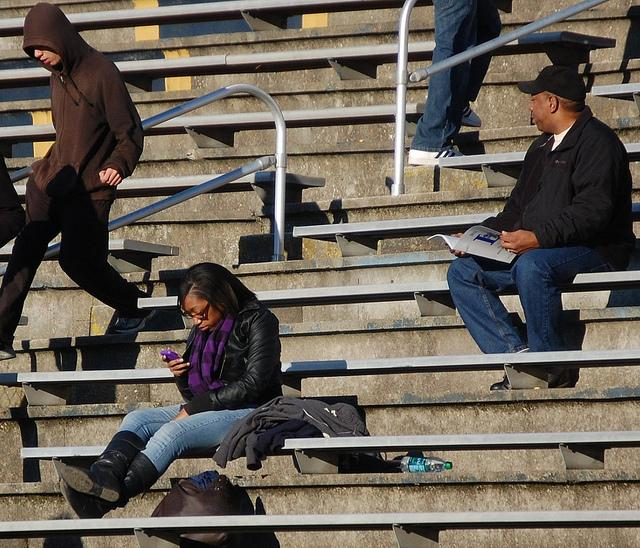What are the people sitting on? Please explain your reasoning. bleachers. Bleachers are flat seats which ascend a sloping structure and that describes this seating, which means these are bleachers. 